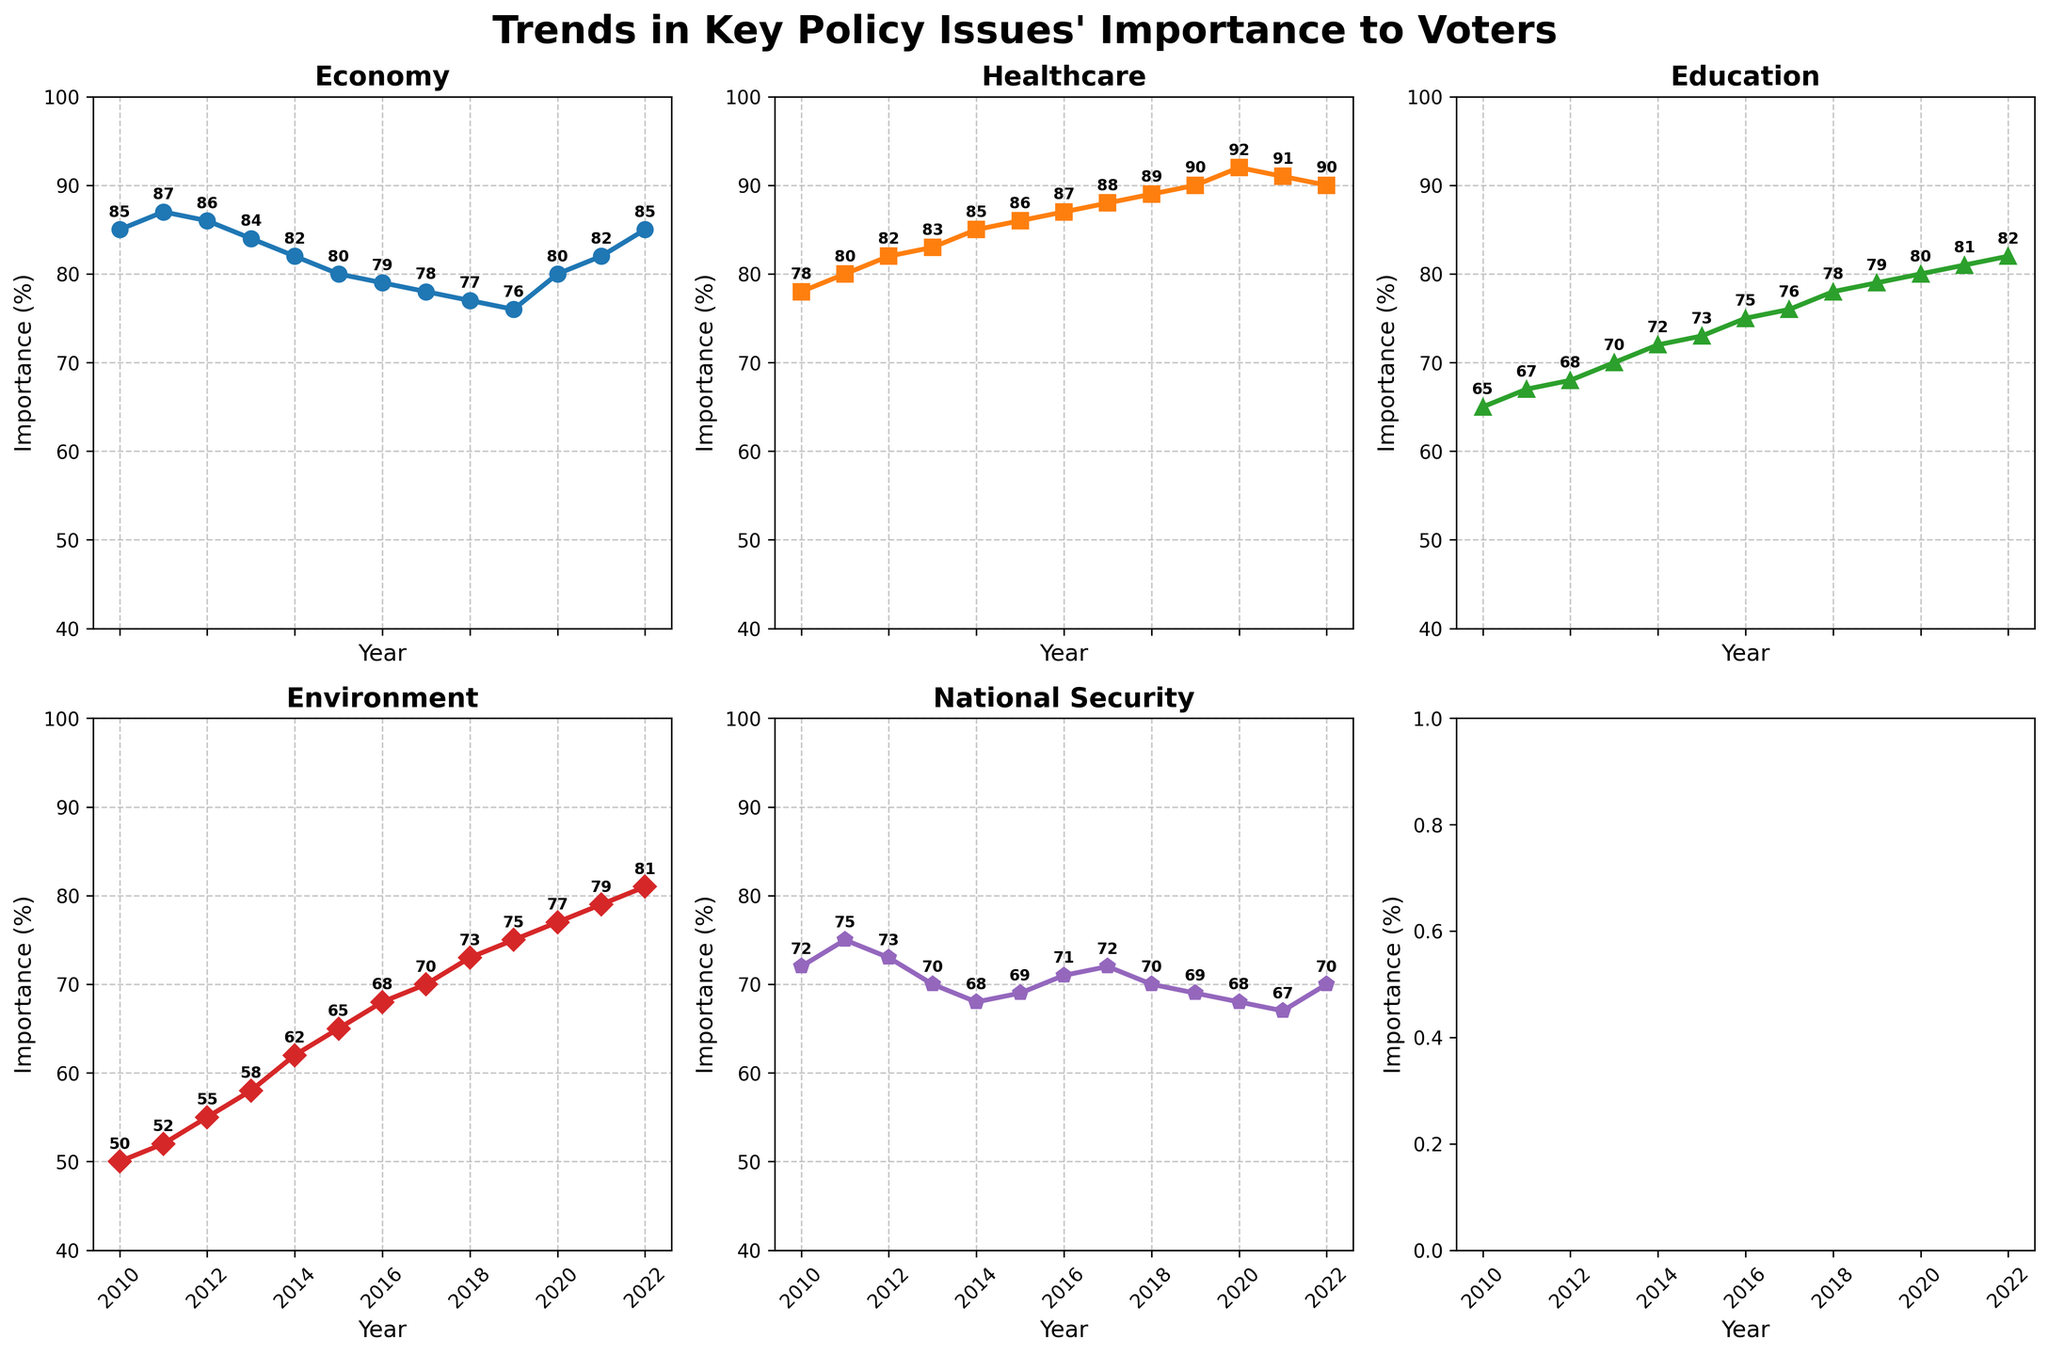Which policy issue had the highest importance to voters in 2022? For 2022, we look at the highest value across all subplots. The highest value is for Healthcare at 90%.
Answer: Healthcare How did the importance of the Economy change from 2010 to 2022? We check the value for the Economy in 2010 and 2022. In 2010, it was 85, and in 2022, it was 85. The importance remained the same.
Answer: No change Which policy issue saw the most consistent increase in importance over the years? We need to assess the trends over time for each issue. Healthcare consistently increased from 78 in 2010 to 92 in 2020 before slightly dropping to 90 in 2022.
Answer: Healthcare In which year did National Security see its largest decrease in importance? We must find the year with the steepest drop in National Security values. The biggest decrease was from 2013 (70) to 2014 (68).
Answer: 2014 What's the total sum of importance values across all policy issues for the year 2015? Add the importance values for all issues: 80 (Economy) + 86 (Healthcare) + 73 (Education) + 65 (Environment) + 69 (National Security) = 373.
Answer: 373 How did the importance of Environment change from 2016 to 2018? The Environment value in 2016 was 68, and in 2018 it was 73. The change is 73 - 68 = 5.
Answer: Increased by 5 Which policy issue had the least variation in importance over the years? We examine the range (max - min) of each issue's values. National Security varied the least, from 67 to 75, a range of 8.
Answer: National Security Between 2016 and 2020, did Education or National Security see a greater increase in importance? For Education: 80 (2020) - 75 (2016) = 5. For National Security: 68 (2020) - 71 (2016) = -3. Education saw a greater increase.
Answer: Education 